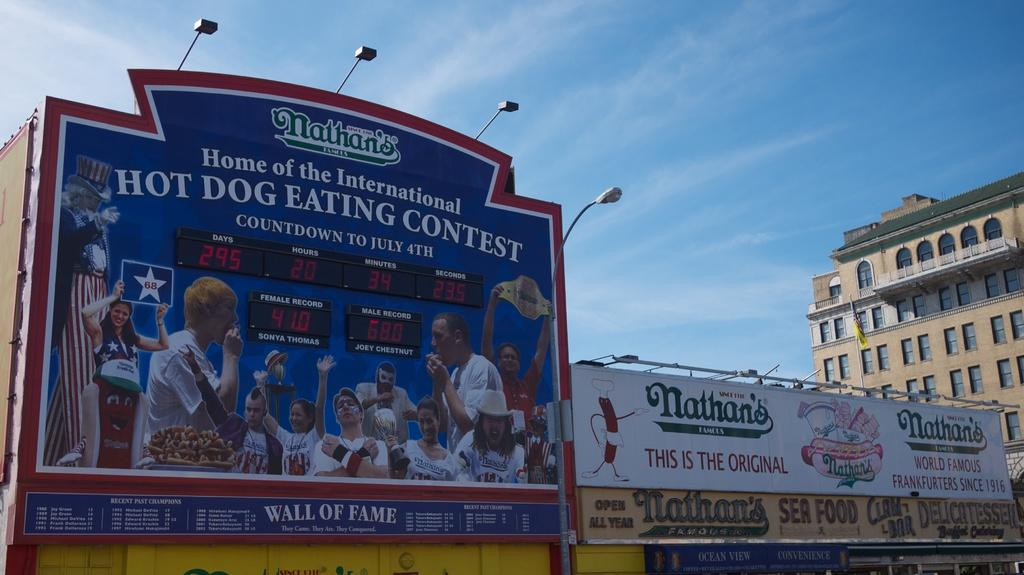<image>
Create a compact narrative representing the image presented. A billboard for a hotdog eating contest can be seen. 